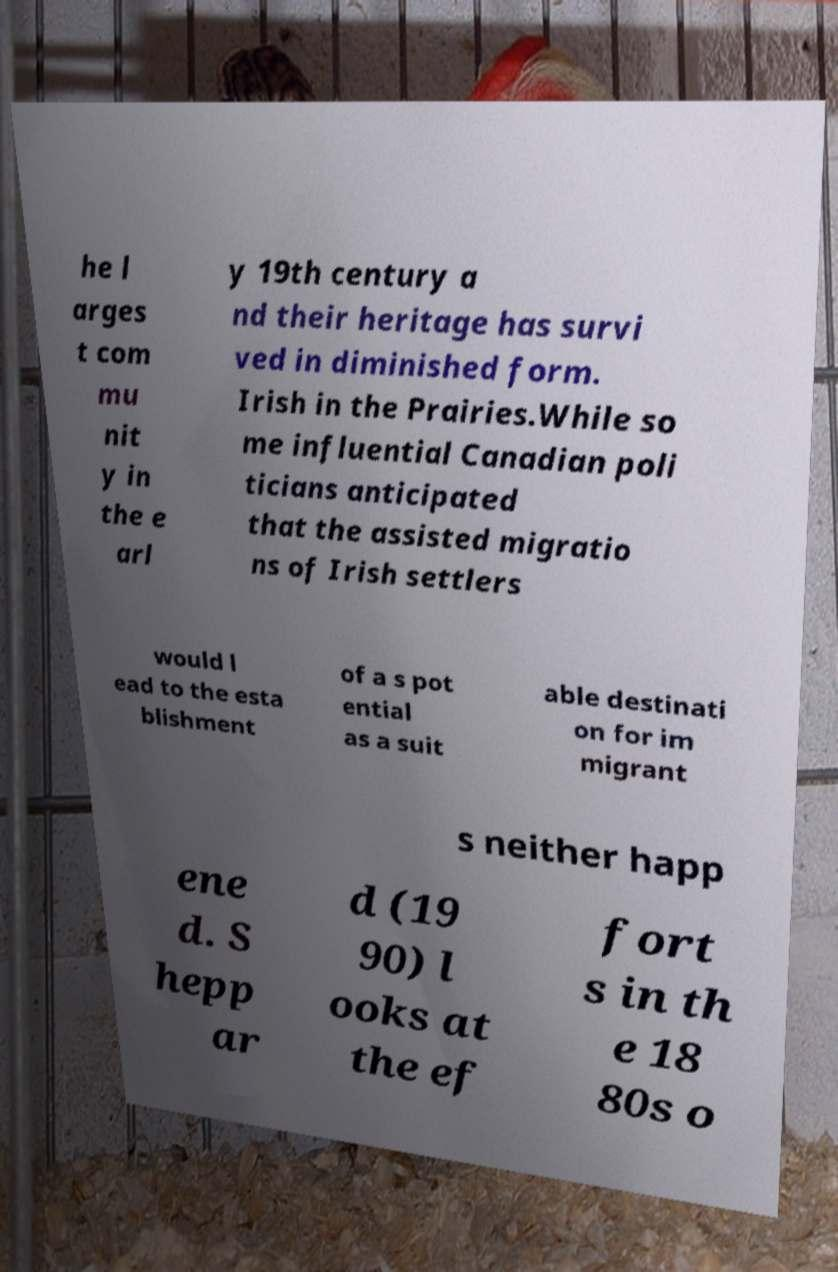What messages or text are displayed in this image? I need them in a readable, typed format. he l arges t com mu nit y in the e arl y 19th century a nd their heritage has survi ved in diminished form. Irish in the Prairies.While so me influential Canadian poli ticians anticipated that the assisted migratio ns of Irish settlers would l ead to the esta blishment of a s pot ential as a suit able destinati on for im migrant s neither happ ene d. S hepp ar d (19 90) l ooks at the ef fort s in th e 18 80s o 